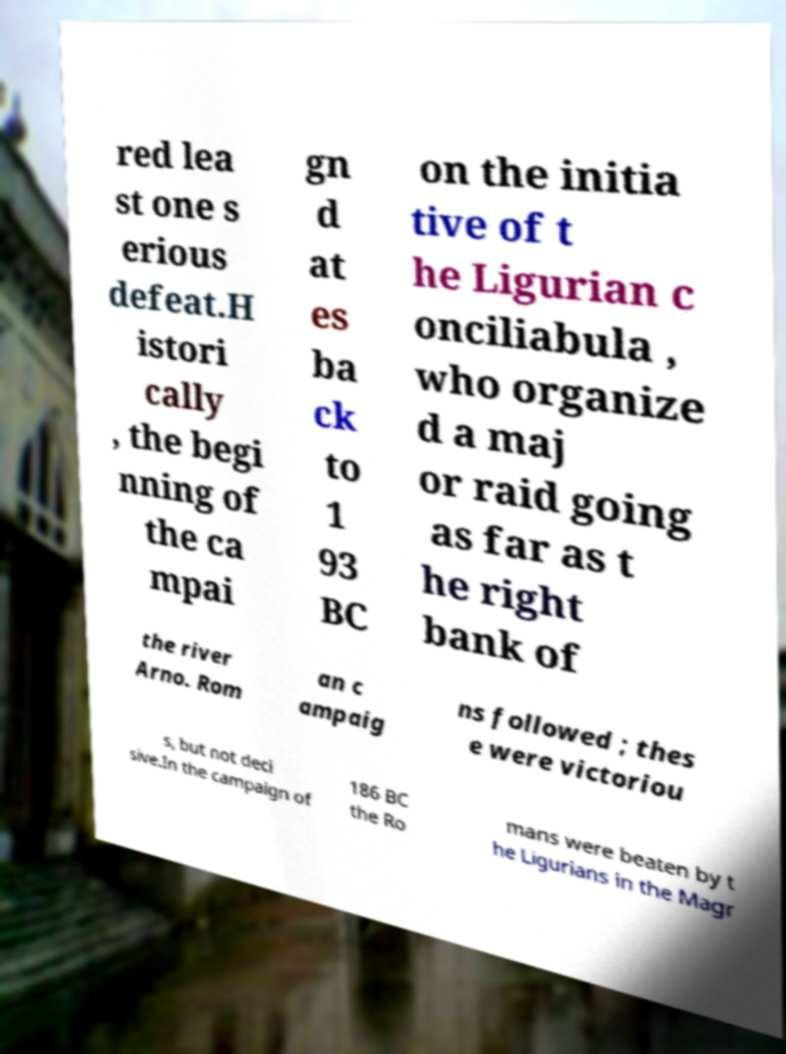Could you extract and type out the text from this image? red lea st one s erious defeat.H istori cally , the begi nning of the ca mpai gn d at es ba ck to 1 93 BC on the initia tive of t he Ligurian c onciliabula , who organize d a maj or raid going as far as t he right bank of the river Arno. Rom an c ampaig ns followed ; thes e were victoriou s, but not deci sive.In the campaign of 186 BC the Ro mans were beaten by t he Ligurians in the Magr 